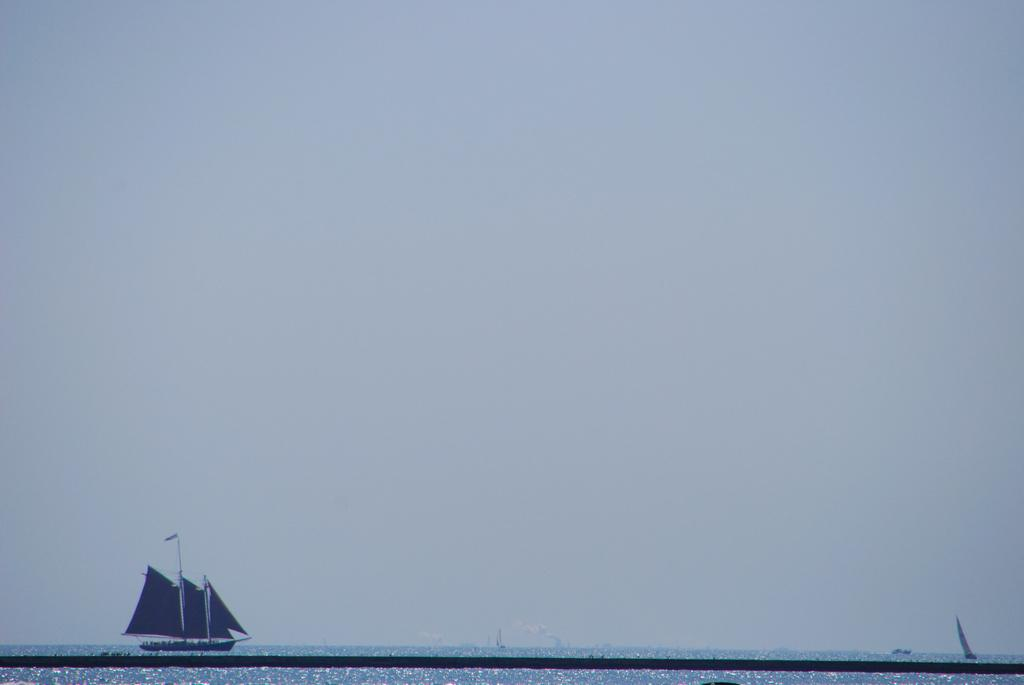What is the main subject of the image? The main subject of the image is a boat. What is located at the bottom of the image? There is water at the bottom of the image. What is located at the top of the image? There is sky at the top of the image. What type of mark can be seen on the boat's hull in the image? There is no mark visible on the boat's hull in the image. What type of destruction is happening to the boat in the image? There is no destruction happening to the boat in the image; it appears to be floating on the water. 